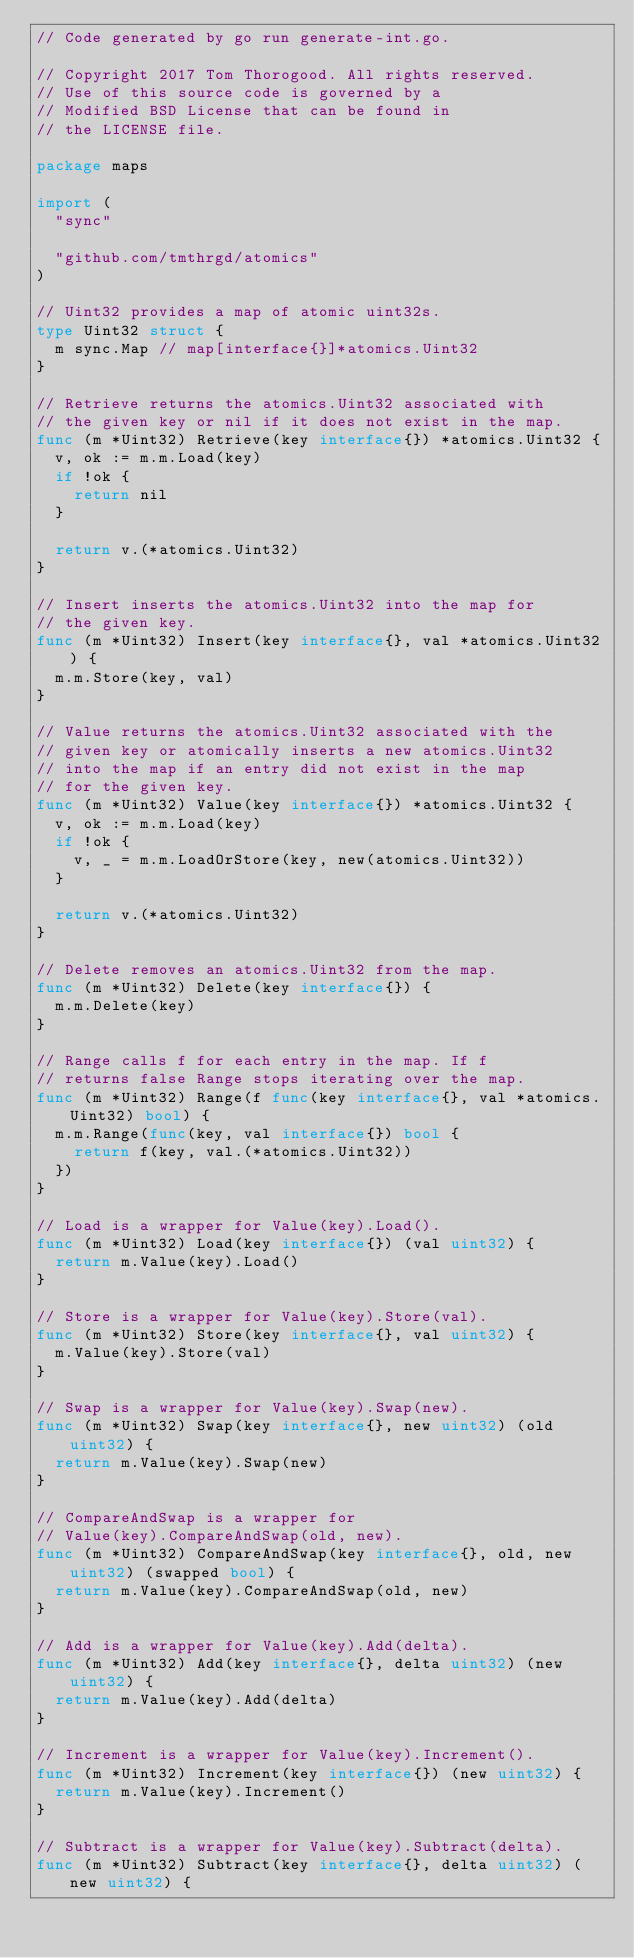Convert code to text. <code><loc_0><loc_0><loc_500><loc_500><_Go_>// Code generated by go run generate-int.go.

// Copyright 2017 Tom Thorogood. All rights reserved.
// Use of this source code is governed by a
// Modified BSD License that can be found in
// the LICENSE file.

package maps

import (
	"sync"

	"github.com/tmthrgd/atomics"
)

// Uint32 provides a map of atomic uint32s.
type Uint32 struct {
	m sync.Map // map[interface{}]*atomics.Uint32
}

// Retrieve returns the atomics.Uint32 associated with
// the given key or nil if it does not exist in the map.
func (m *Uint32) Retrieve(key interface{}) *atomics.Uint32 {
	v, ok := m.m.Load(key)
	if !ok {
		return nil
	}

	return v.(*atomics.Uint32)
}

// Insert inserts the atomics.Uint32 into the map for
// the given key.
func (m *Uint32) Insert(key interface{}, val *atomics.Uint32) {
	m.m.Store(key, val)
}

// Value returns the atomics.Uint32 associated with the
// given key or atomically inserts a new atomics.Uint32
// into the map if an entry did not exist in the map
// for the given key.
func (m *Uint32) Value(key interface{}) *atomics.Uint32 {
	v, ok := m.m.Load(key)
	if !ok {
		v, _ = m.m.LoadOrStore(key, new(atomics.Uint32))
	}

	return v.(*atomics.Uint32)
}

// Delete removes an atomics.Uint32 from the map.
func (m *Uint32) Delete(key interface{}) {
	m.m.Delete(key)
}

// Range calls f for each entry in the map. If f
// returns false Range stops iterating over the map.
func (m *Uint32) Range(f func(key interface{}, val *atomics.Uint32) bool) {
	m.m.Range(func(key, val interface{}) bool {
		return f(key, val.(*atomics.Uint32))
	})
}

// Load is a wrapper for Value(key).Load().
func (m *Uint32) Load(key interface{}) (val uint32) {
	return m.Value(key).Load()
}

// Store is a wrapper for Value(key).Store(val).
func (m *Uint32) Store(key interface{}, val uint32) {
	m.Value(key).Store(val)
}

// Swap is a wrapper for Value(key).Swap(new).
func (m *Uint32) Swap(key interface{}, new uint32) (old uint32) {
	return m.Value(key).Swap(new)
}

// CompareAndSwap is a wrapper for
// Value(key).CompareAndSwap(old, new).
func (m *Uint32) CompareAndSwap(key interface{}, old, new uint32) (swapped bool) {
	return m.Value(key).CompareAndSwap(old, new)
}

// Add is a wrapper for Value(key).Add(delta).
func (m *Uint32) Add(key interface{}, delta uint32) (new uint32) {
	return m.Value(key).Add(delta)
}

// Increment is a wrapper for Value(key).Increment().
func (m *Uint32) Increment(key interface{}) (new uint32) {
	return m.Value(key).Increment()
}

// Subtract is a wrapper for Value(key).Subtract(delta).
func (m *Uint32) Subtract(key interface{}, delta uint32) (new uint32) {</code> 